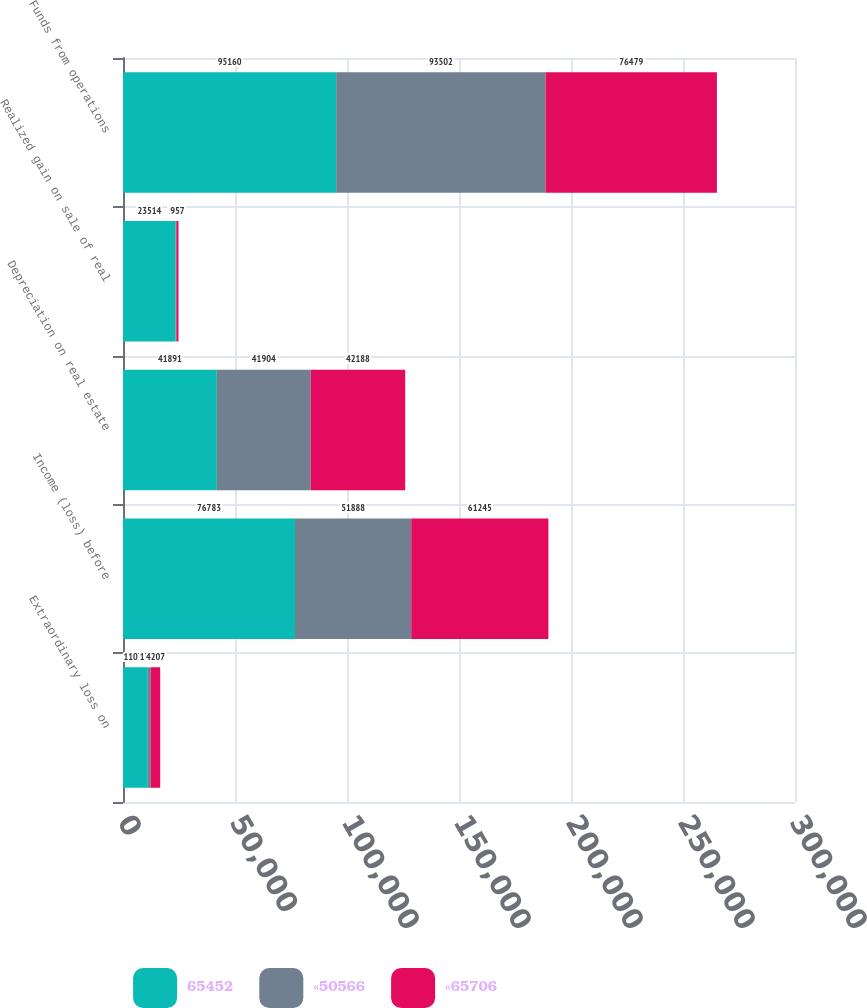Convert chart to OTSL. <chart><loc_0><loc_0><loc_500><loc_500><stacked_bar_chart><ecel><fcel>Extraordinary loss on<fcel>Income (loss) before<fcel>Depreciation on real estate<fcel>Realized gain on sale of real<fcel>Funds from operations<nl><fcel>65452<fcel>11077<fcel>76783<fcel>41891<fcel>23514<fcel>95160<nl><fcel>«50566<fcel>1322<fcel>51888<fcel>41904<fcel>290<fcel>93502<nl><fcel>«65706<fcel>4207<fcel>61245<fcel>42188<fcel>957<fcel>76479<nl></chart> 